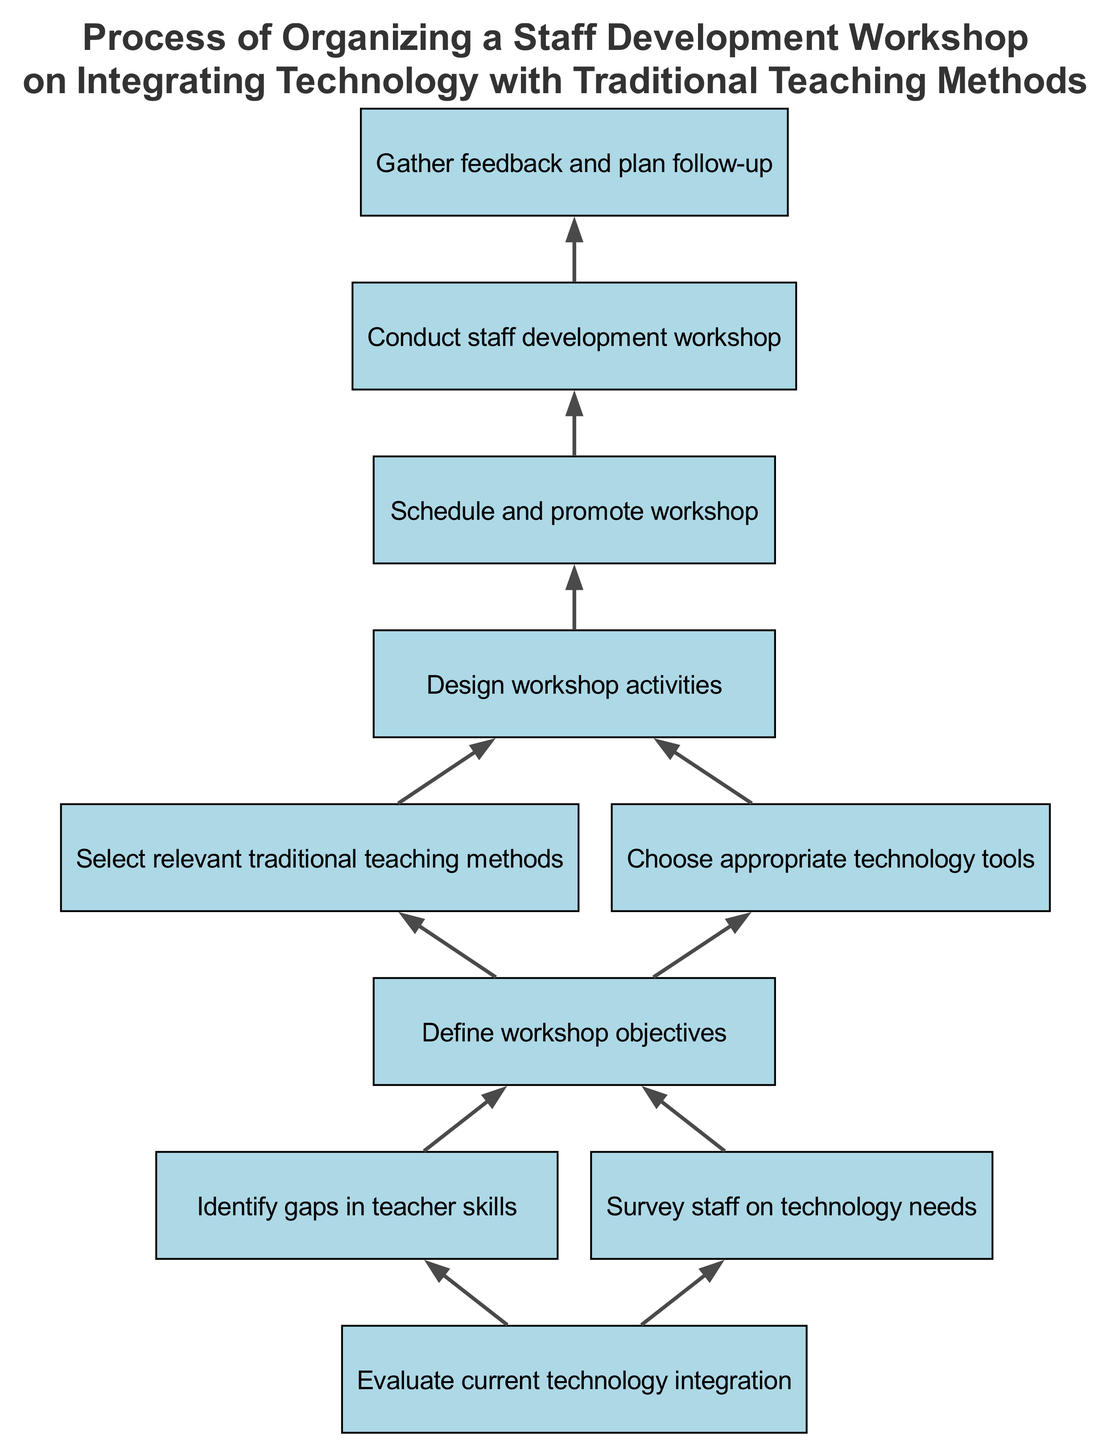What is the first step in the process? The first step in the process, as indicated at the base of the diagram, is "Evaluate current technology integration." This is the starting point that leads to further actions in the flow.
Answer: Evaluate current technology integration How many connections does the node "Define workshop objectives" have? Upon inspecting the diagram, the node "Define workshop objectives" is connected to two nodes, which are "Select relevant traditional teaching methods" and "Choose appropriate technology tools." Therefore, it has two connections.
Answer: 2 What are the two follow-up actions after gathering feedback? From the diagram, after the "Conduct staff development workshop" node, there is one action leading to "Gather feedback and plan follow-up." There are no additional nodes connected; thus, the follow-up action is encompassed in this node.
Answer: Gather feedback and plan follow-up Which steps are taken after identifying gaps in teacher skills? Following the step of "Identify gaps in teacher skills," the next action in the flow is "Define workshop objectives." This indicates that once the gaps are identified, objectives for the workshop are set.
Answer: Define workshop objectives What leads directly to designing workshop activities? "Define workshop objectives" is the step that directly leads to "Design workshop activities." The design of the workshop’s activities is contingent upon the objectives that have been established.
Answer: Define workshop objectives What is the final step in the process? The last step in the diagram is "Gather feedback and plan follow-up," which signifies the completion of the workshop process and the importance of evaluating its effectiveness.
Answer: Gather feedback and plan follow-up Which two nodes have connections from the node "Evaluate current technology integration"? The node "Evaluate current technology integration" connects to two subsequent actions: "Identify gaps in teacher skills" and "Survey staff on technology needs." This indicates that evaluating technology leads to identifying skills and understanding staff needs.
Answer: Identify gaps in teacher skills, Survey staff on technology needs What type of relationship exists between "Choose appropriate technology tools" and "Design workshop activities"? The relationship between "Choose appropriate technology tools" and "Design workshop activities" is sequential, meaning that choosing tools is necessary before the design of workshop activities can take place.
Answer: Sequential 